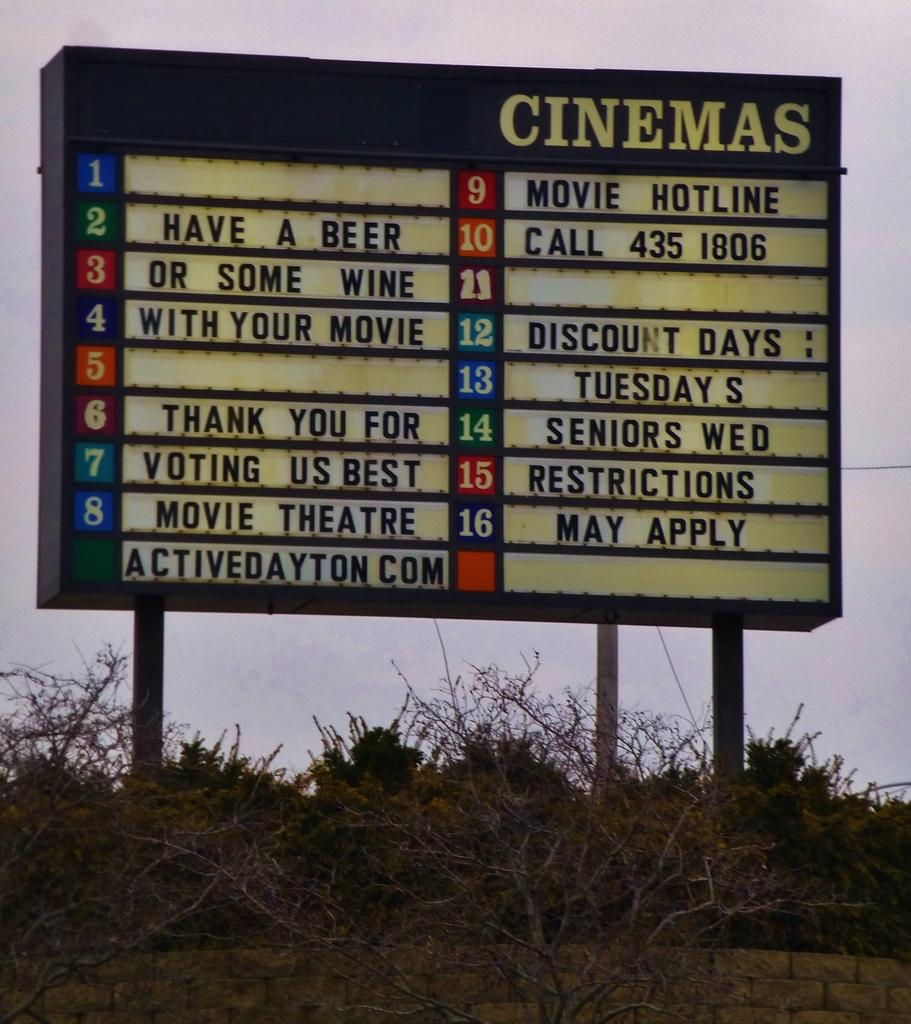<image>
Summarize the visual content of the image. a signage with sayings, one reads HAVE A BEER OR SOME WINE WITH YOUR MOVIE. 